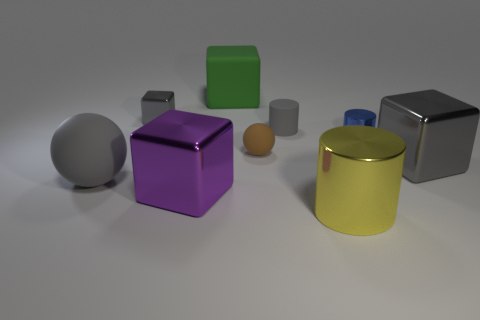Add 1 yellow objects. How many objects exist? 10 Subtract all metallic blocks. How many blocks are left? 1 Subtract all green blocks. How many blocks are left? 3 Subtract all blocks. How many objects are left? 5 Add 8 purple metal blocks. How many purple metal blocks are left? 9 Add 5 tiny purple metal objects. How many tiny purple metal objects exist? 5 Subtract 1 green cubes. How many objects are left? 8 Subtract 3 cubes. How many cubes are left? 1 Subtract all cyan spheres. Subtract all red cylinders. How many spheres are left? 2 Subtract all purple cubes. How many red cylinders are left? 0 